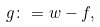<formula> <loc_0><loc_0><loc_500><loc_500>g \colon = w - f ,</formula> 